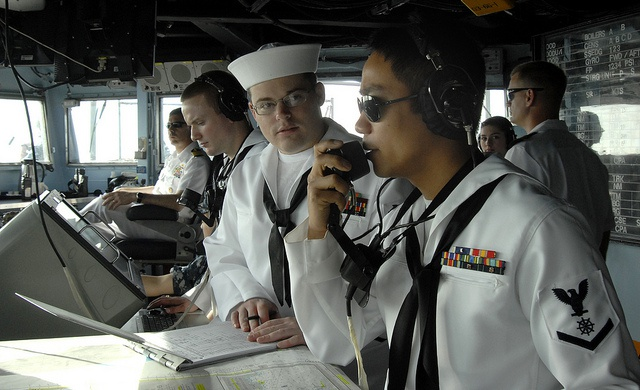Describe the objects in this image and their specific colors. I can see people in gray, black, darkgray, and maroon tones, people in gray, darkgray, black, and lightgray tones, people in gray and black tones, tie in gray, black, darkgray, and lightgray tones, and laptop in gray, darkgray, ivory, and black tones in this image. 